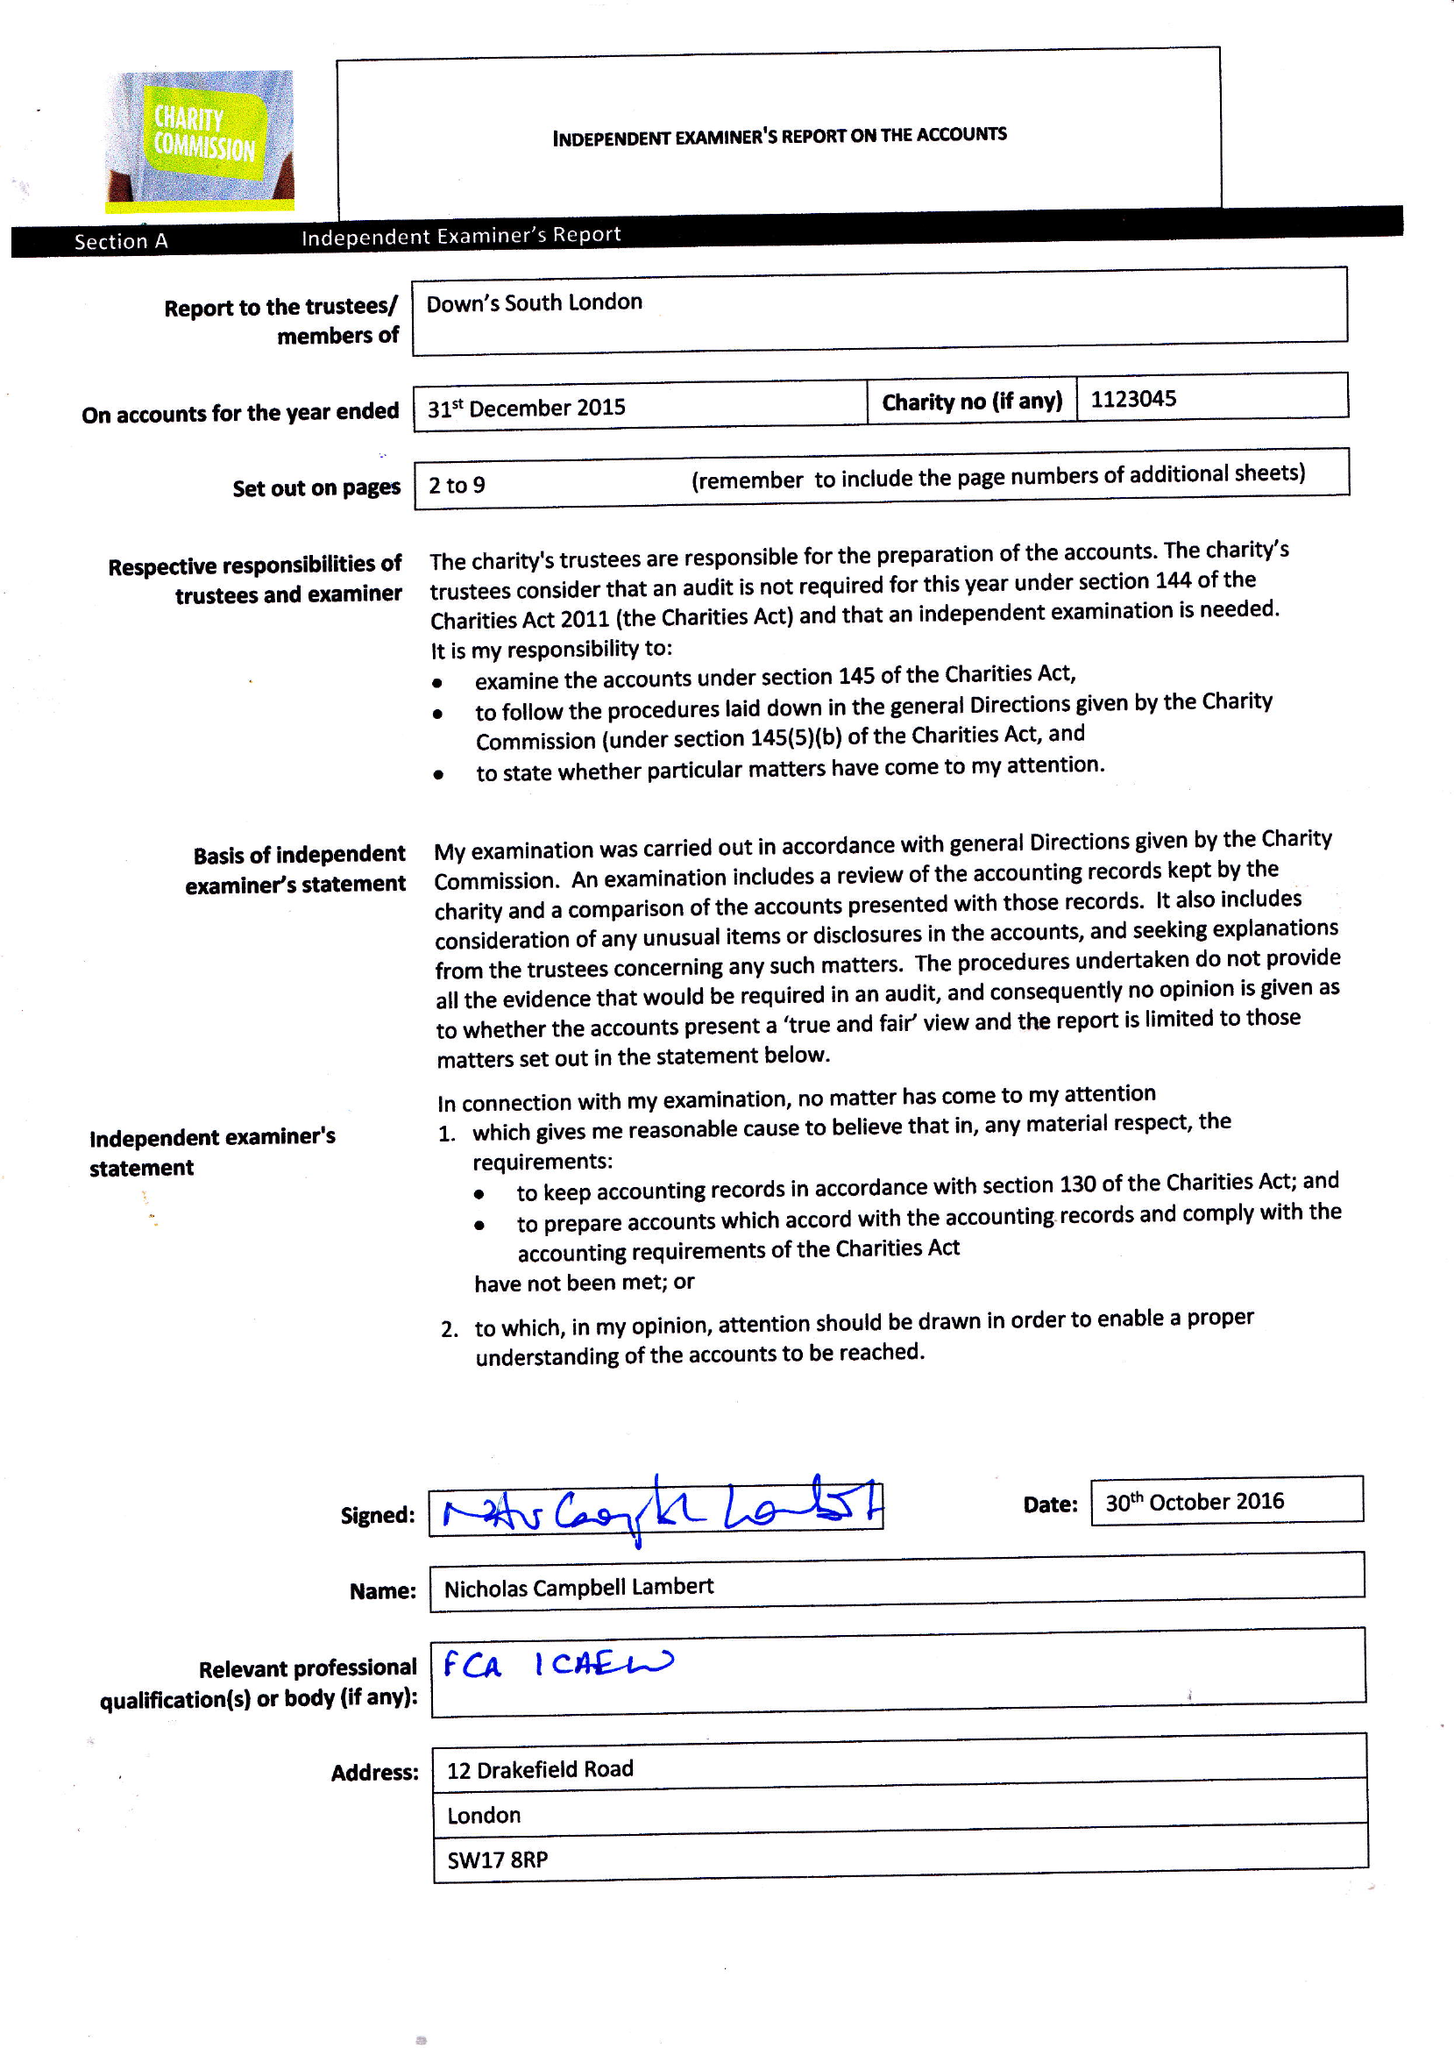What is the value for the address__post_town?
Answer the question using a single word or phrase. LONDON 